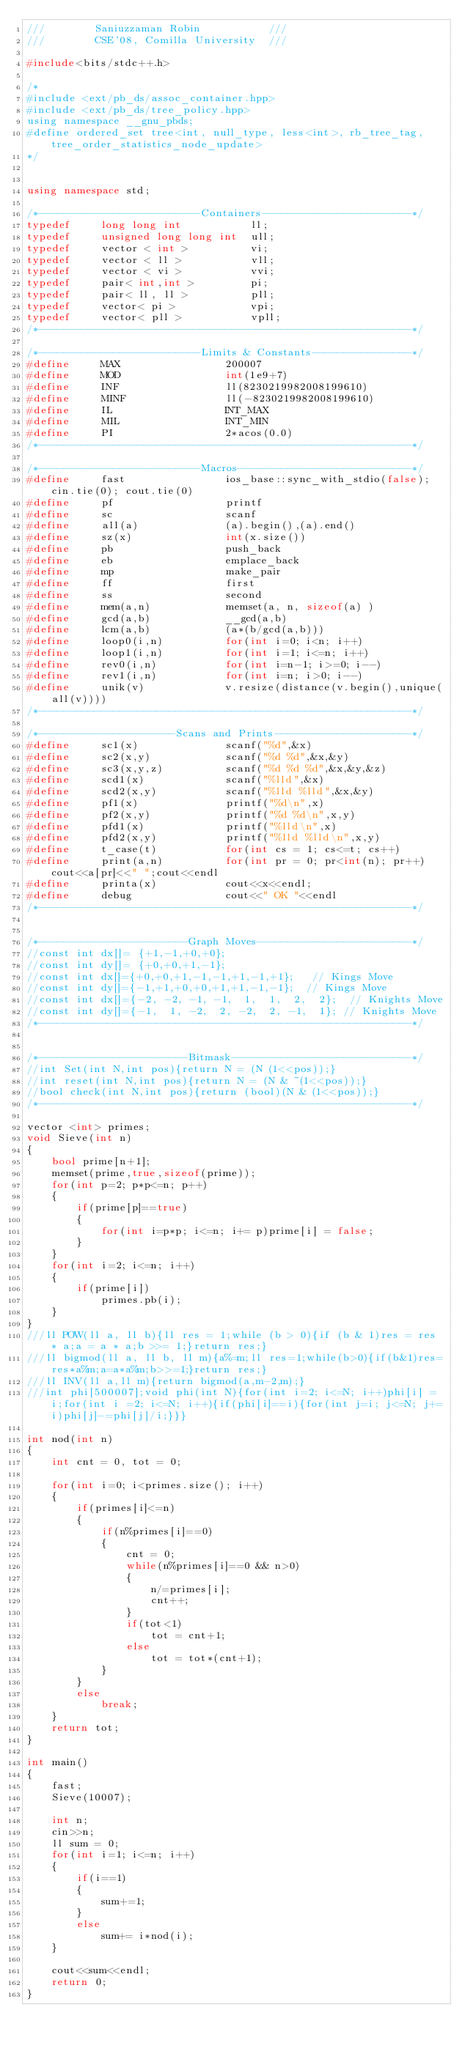<code> <loc_0><loc_0><loc_500><loc_500><_C++_>///        Saniuzzaman Robin           ///
///        CSE'08, Comilla University  ///

#include<bits/stdc++.h>

/*
#include <ext/pb_ds/assoc_container.hpp>
#include <ext/pb_ds/tree_policy.hpp>
using namespace __gnu_pbds;
#define ordered_set tree<int, null_type, less<int>, rb_tree_tag, tree_order_statistics_node_update>
*/


using namespace std;

/*--------------------------Containers------------------------*/
typedef     long long int           ll;
typedef     unsigned long long int  ull;
typedef     vector < int >          vi;
typedef     vector < ll >           vll;
typedef     vector < vi >           vvi;
typedef     pair< int,int >         pi;
typedef     pair< ll, ll >          pll;
typedef     vector< pi >            vpi;
typedef     vector< pll >           vpll;
/*------------------------------------------------------------*/

/*--------------------------Limits & Constants----------------*/
#define     MAX                 200007
#define     MOD                 int(1e9+7)
#define     INF                 ll(8230219982008199610)
#define     MINF                ll(-8230219982008199610)
#define     IL                  INT_MAX
#define     MIL                 INT_MIN
#define     PI                  2*acos(0.0)
/*------------------------------------------------------------*/

/*--------------------------Macros----------------------------*/
#define     fast                ios_base::sync_with_stdio(false);cin.tie(0); cout.tie(0)
#define     pf                  printf
#define     sc                  scanf
#define     all(a)              (a).begin(),(a).end()
#define     sz(x)               int(x.size())
#define     pb                  push_back
#define     eb                  emplace_back
#define     mp                  make_pair
#define     ff                  first
#define     ss                  second
#define     mem(a,n)            memset(a, n, sizeof(a) )
#define     gcd(a,b)            __gcd(a,b)
#define     lcm(a,b)            (a*(b/gcd(a,b)))
#define     loop0(i,n)          for(int i=0; i<n; i++)
#define     loop1(i,n)          for(int i=1; i<=n; i++)
#define     rev0(i,n)           for(int i=n-1; i>=0; i--)
#define     rev1(i,n)           for(int i=n; i>0; i--)
#define     unik(v)             v.resize(distance(v.begin(),unique(all(v))))
/*------------------------------------------------------------*/

/*----------------------Scans and Prints----------------------*/
#define     sc1(x)              scanf("%d",&x)
#define     sc2(x,y)            scanf("%d %d",&x,&y)
#define     sc3(x,y,z)          scanf("%d %d %d",&x,&y,&z)
#define     scd1(x)             scanf("%lld",&x)
#define     scd2(x,y)           scanf("%lld %lld",&x,&y)
#define     pf1(x)              printf("%d\n",x)
#define     pf2(x,y)            printf("%d %d\n",x,y)
#define     pfd1(x)             printf("%lld\n",x)
#define     pfd2(x,y)           printf("%lld %lld\n",x,y)
#define     t_case(t)           for(int cs = 1; cs<=t; cs++)
#define     print(a,n)          for(int pr = 0; pr<int(n); pr++)cout<<a[pr]<<" ";cout<<endl
#define     printa(x)           cout<<x<<endl;
#define     debug               cout<<" OK "<<endl
/*------------------------------------------------------------*/


/*------------------------Graph Moves-------------------------*/
//const int dx[]= {+1,-1,+0,+0};
//const int dy[]= {+0,+0,+1,-1};
//const int dx[]={+0,+0,+1,-1,-1,+1,-1,+1};   // Kings Move
//const int dy[]={-1,+1,+0,+0,+1,+1,-1,-1};  // Kings Move
//const int dx[]={-2, -2, -1, -1,  1,  1,  2,  2};  // Knights Move
//const int dy[]={-1,  1, -2,  2, -2,  2, -1,  1}; // Knights Move
/*------------------------------------------------------------*/


/*------------------------Bitmask-----------------------------*/
//int Set(int N,int pos){return N = (N (1<<pos));}
//int reset(int N,int pos){return N = (N & ~(1<<pos));}
//bool check(int N,int pos){return (bool)(N & (1<<pos));}
/*------------------------------------------------------------*/

vector <int> primes;
void Sieve(int n)
{
    bool prime[n+1];
    memset(prime,true,sizeof(prime));
    for(int p=2; p*p<=n; p++)
    {
        if(prime[p]==true)
        {
            for(int i=p*p; i<=n; i+= p)prime[i] = false;
        }
    }
    for(int i=2; i<=n; i++)
    {
        if(prime[i])
            primes.pb(i);
    }
}
///ll POW(ll a, ll b){ll res = 1;while (b > 0){if (b & 1)res = res * a;a = a * a;b >>= 1;}return res;}
///ll bigmod(ll a, ll b, ll m){a%=m;ll res=1;while(b>0){if(b&1)res=res*a%m;a=a*a%m;b>>=1;}return res;}
///ll INV(ll a,ll m){return bigmod(a,m-2,m);}
///int phi[500007];void phi(int N){for(int i=2; i<=N; i++)phi[i] = i;for(int i =2; i<=N; i++){if(phi[i]==i){for(int j=i; j<=N; j+=i)phi[j]-=phi[j]/i;}}}

int nod(int n)
{
    int cnt = 0, tot = 0;

    for(int i=0; i<primes.size(); i++)
    {
        if(primes[i]<=n)
        {
            if(n%primes[i]==0)
            {
                cnt = 0;
                while(n%primes[i]==0 && n>0)
                {
                    n/=primes[i];
                    cnt++;
                }
                if(tot<1)
                    tot = cnt+1;
                else
                    tot = tot*(cnt+1);
            }
        }
        else
            break;
    }
    return tot;
}

int main()
{
    fast;
    Sieve(10007);

    int n;
    cin>>n;
    ll sum = 0;
    for(int i=1; i<=n; i++)
    {
        if(i==1)
        {
            sum+=1;
        }
        else
            sum+= i*nod(i);
    }

    cout<<sum<<endl;
    return 0;
}
</code> 